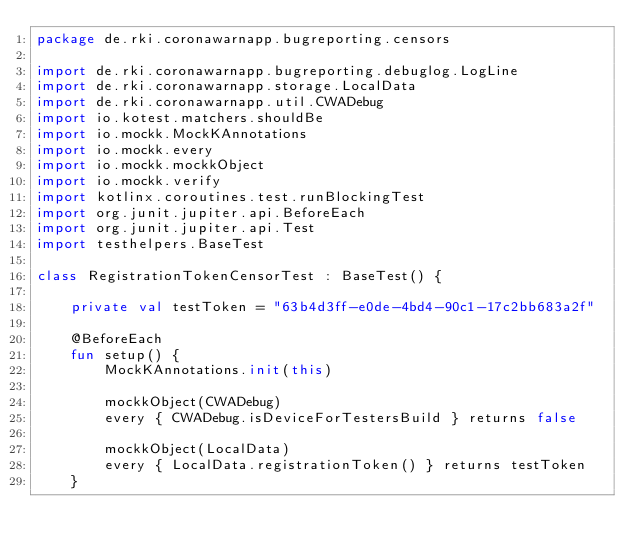Convert code to text. <code><loc_0><loc_0><loc_500><loc_500><_Kotlin_>package de.rki.coronawarnapp.bugreporting.censors

import de.rki.coronawarnapp.bugreporting.debuglog.LogLine
import de.rki.coronawarnapp.storage.LocalData
import de.rki.coronawarnapp.util.CWADebug
import io.kotest.matchers.shouldBe
import io.mockk.MockKAnnotations
import io.mockk.every
import io.mockk.mockkObject
import io.mockk.verify
import kotlinx.coroutines.test.runBlockingTest
import org.junit.jupiter.api.BeforeEach
import org.junit.jupiter.api.Test
import testhelpers.BaseTest

class RegistrationTokenCensorTest : BaseTest() {

    private val testToken = "63b4d3ff-e0de-4bd4-90c1-17c2bb683a2f"

    @BeforeEach
    fun setup() {
        MockKAnnotations.init(this)

        mockkObject(CWADebug)
        every { CWADebug.isDeviceForTestersBuild } returns false

        mockkObject(LocalData)
        every { LocalData.registrationToken() } returns testToken
    }
</code> 